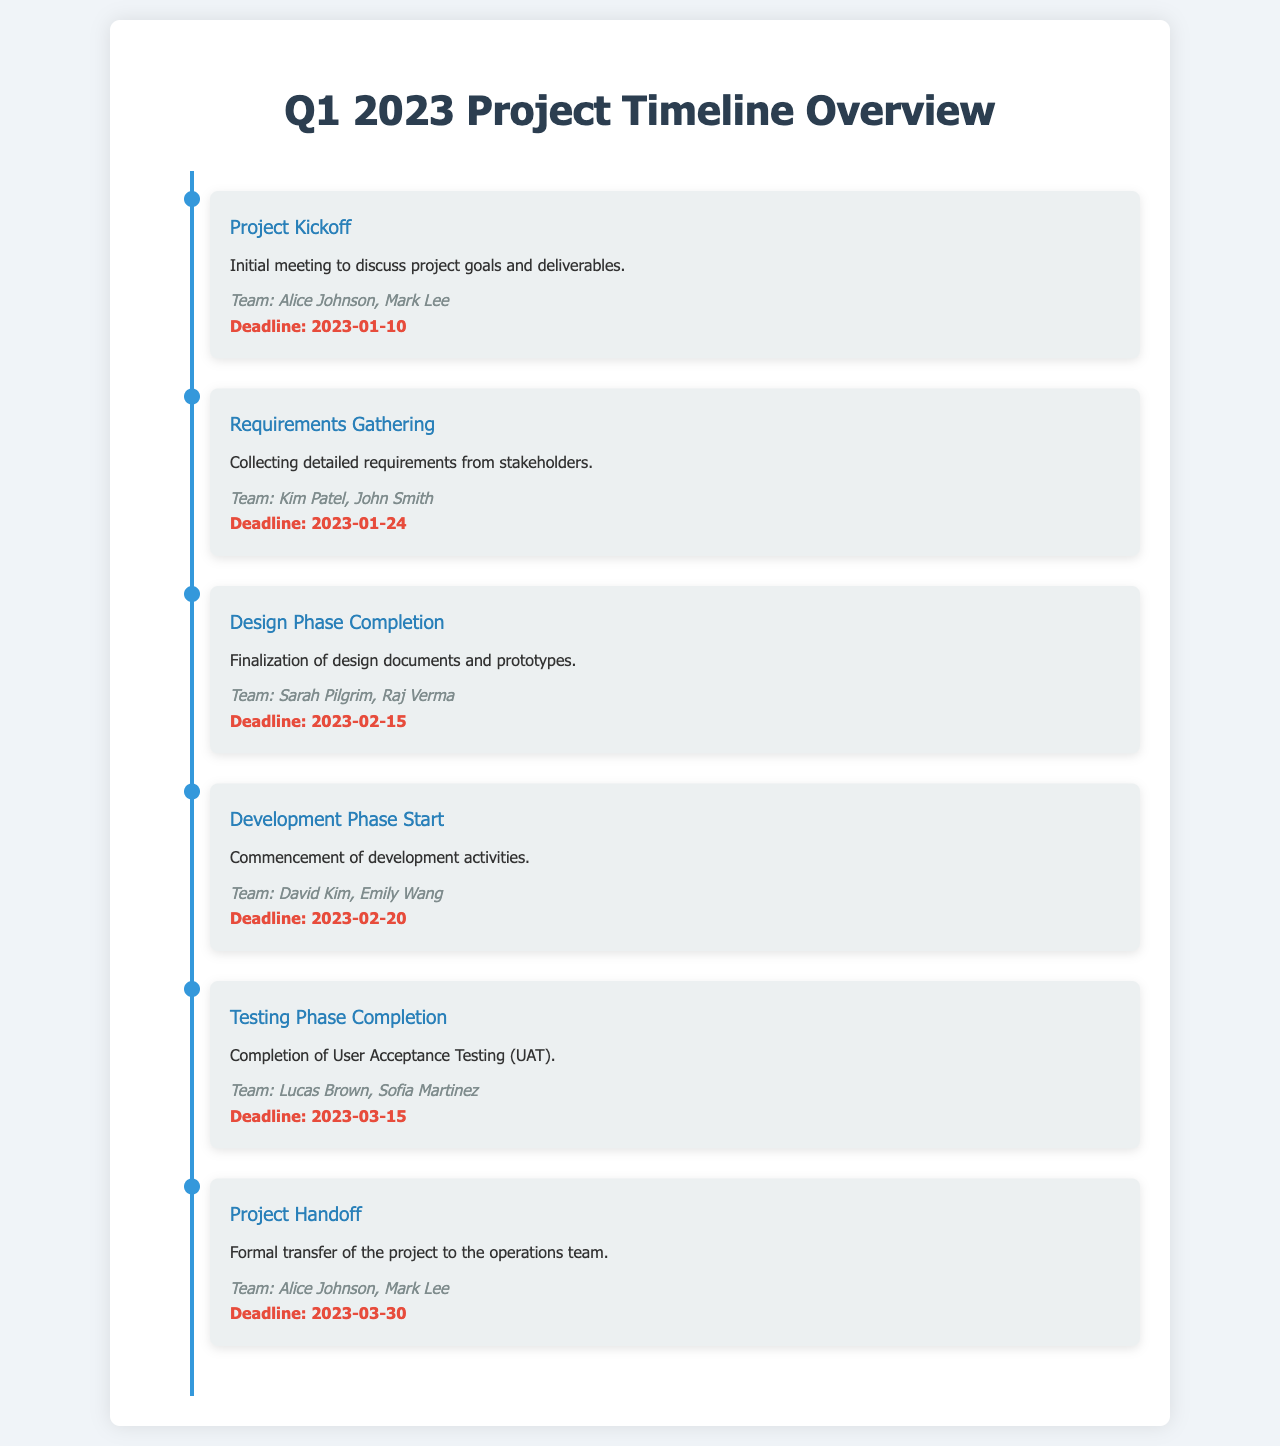What is the deadline for the Project Kickoff? The deadline for the Project Kickoff is specified in the document as the date by which the kickoff meeting should occur.
Answer: 2023-01-10 Who are the responsible team members for the Requirements Gathering? The document lists the names of the team members responsible for the Requirements Gathering phase.
Answer: Kim Patel, John Smith What is the milestone for the completion of User Acceptance Testing? The document describes the Testing Phase Completion as the milestone where UAT is finished.
Answer: Testing Phase Completion When does the Development Phase start? The document specifies the start date for the Development Phase within its timeline.
Answer: 2023-02-20 Which team members are involved in the Design Phase Completion? The document outlines the team members who are assigned to the Design Phase.
Answer: Sarah Pilgrim, Raj Verma How many milestones are listed in the project timeline? The document provides the total number of distinct milestones included in the project timeline overview.
Answer: 6 What is the deadline for the Project Handoff? The document states the date by which the formal transfer to the operations team should be completed.
Answer: 2023-03-30 What represents the midpoint between Requirements Gathering and Development Phase Start? To find this, you need to establish the timeline sequence and identify which milestone falls between these two phases.
Answer: Design Phase Completion What is the primary activity described for the Development Phase? The document outlines the main activities associated with the Development Phase commencement.
Answer: Commencement of development activities 